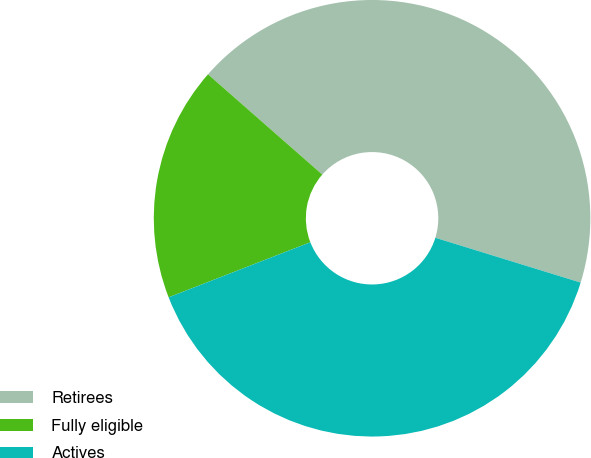Convert chart. <chart><loc_0><loc_0><loc_500><loc_500><pie_chart><fcel>Retirees<fcel>Fully eligible<fcel>Actives<nl><fcel>43.3%<fcel>17.36%<fcel>39.34%<nl></chart> 